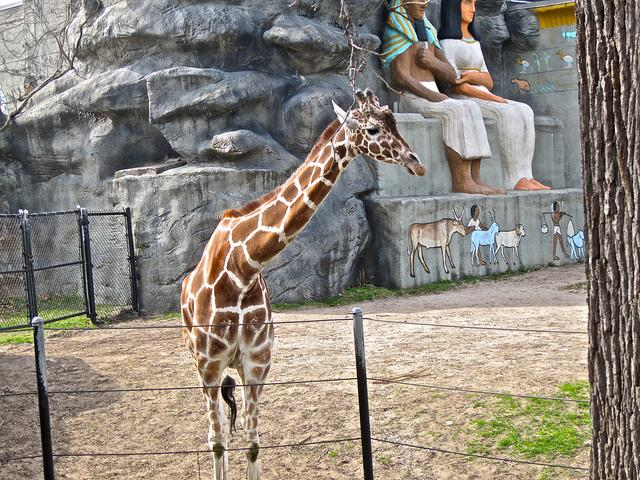Why are the fences lower than the giraffe's neck? to eat 